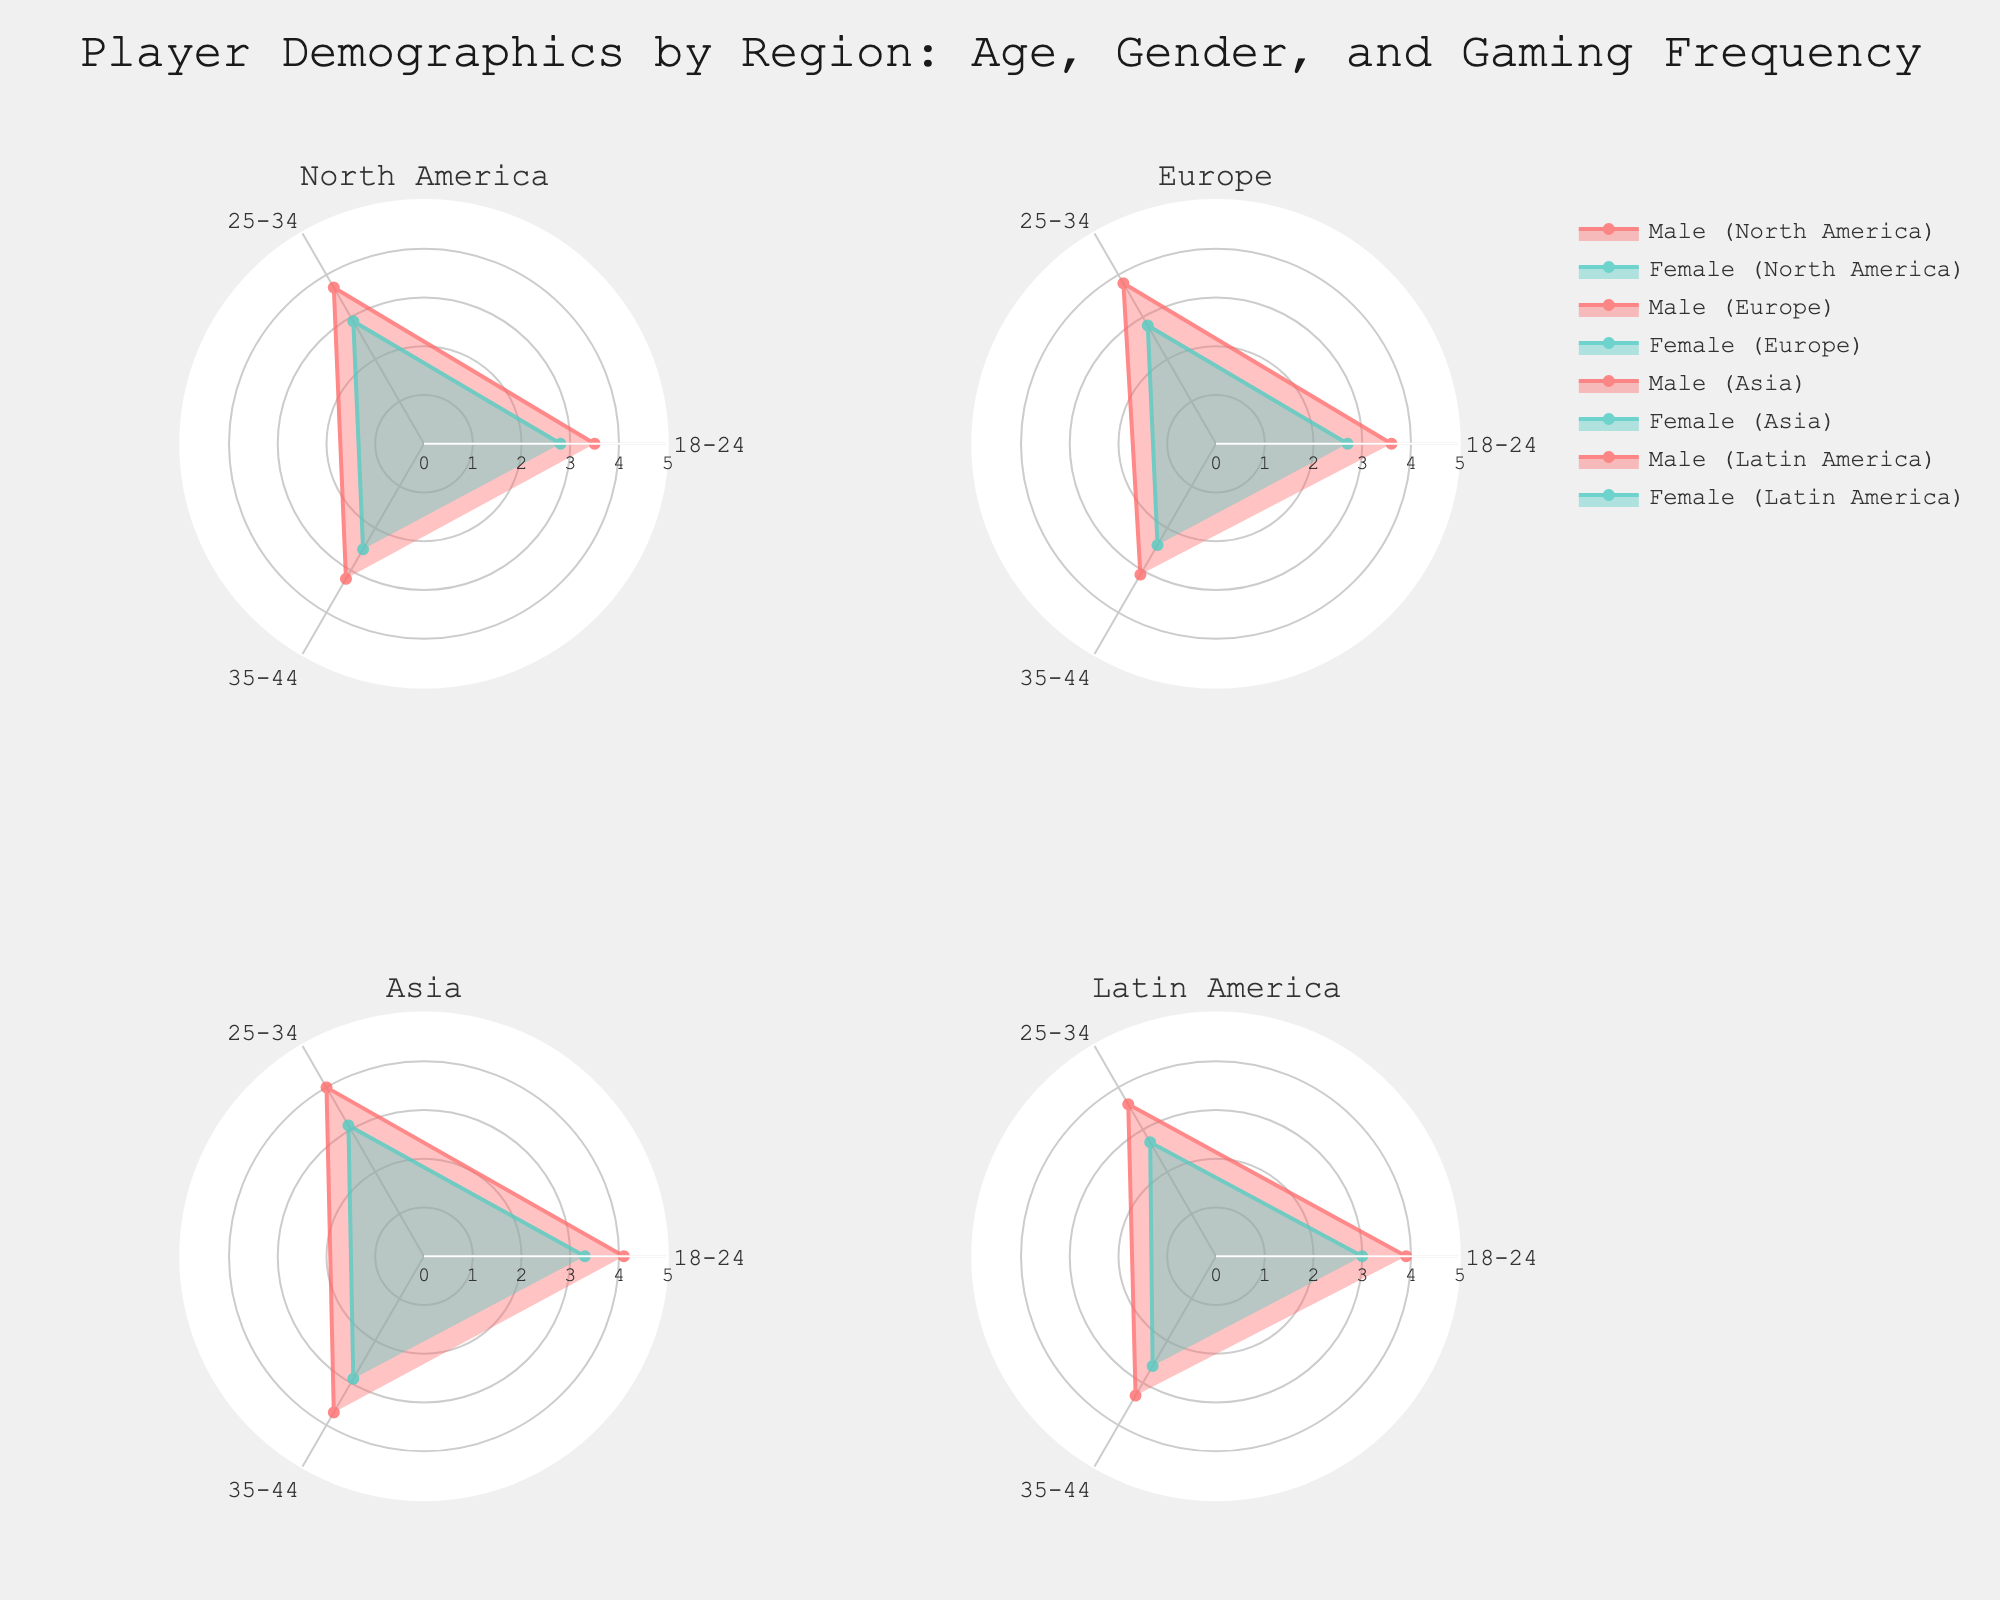What is the title of the figure? The title can be found at the top of the figure. It describes the overall subject and context of the radar charts.
Answer: Player Demographics by Region: Age, Gender, and Gaming Frequency Which gender has the higher gaming frequency in Europe for the age group 25-34? Look at the subplot for Europe and compare the two lines representing males and females at the 25-34 age group on the radar chart.
Answer: Male What is the range of the radial axis in the radar charts? The radial axis range is consistent across all subplots. It can be determined by observing the furthest and closest points from the center.
Answer: 0 to 5 In North America, by how much do male gamers aged 18-24 play more frequently than female gamers of the same age group? Check the North America subplot and find the gaming frequencies for male and female gamers aged 18-24. Subtract the female frequency from the male frequency.
Answer: 0.7 In which region do female gamers aged 18-24 have the highest gaming frequency? Compare the gaming frequencies for female gamers aged 18-24 in all subplots. Identify the region with the highest value.
Answer: Asia Compare the average gaming frequency of males aged 25-34 across all regions. Calculate the average values by summing up the gaming frequencies of males aged 25-34 for all regions and then dividing by the number of regions.
Answer: 3.775 Which age group has the lowest gaming frequency for females in Latin America? Look at the subplot for Latin America and check the frequencies for females across all age groups to find the lowest value.
Answer: 35-44 Compare gaming frequencies for males aged 35-44 and females aged 35-44 in Asia. Which gender games more frequently? Observe the radar chart for Asia and compare the points for males and females aged 35-44. Identify which one is higher.
Answer: Male Which region has the least difference in gaming frequencies between males and females aged 25-34? Calculate the differences between the gaming frequencies of males and females aged 25-34 for each region. Identify the region with the smallest difference.
Answer: North America For which region and gender is the gaming frequency uniformly decreasing with increasing age? Inspect each subplot separately and check if the gaming frequency decreases steadily across all age groups for any specific gender.
Answer: Female in Europe 